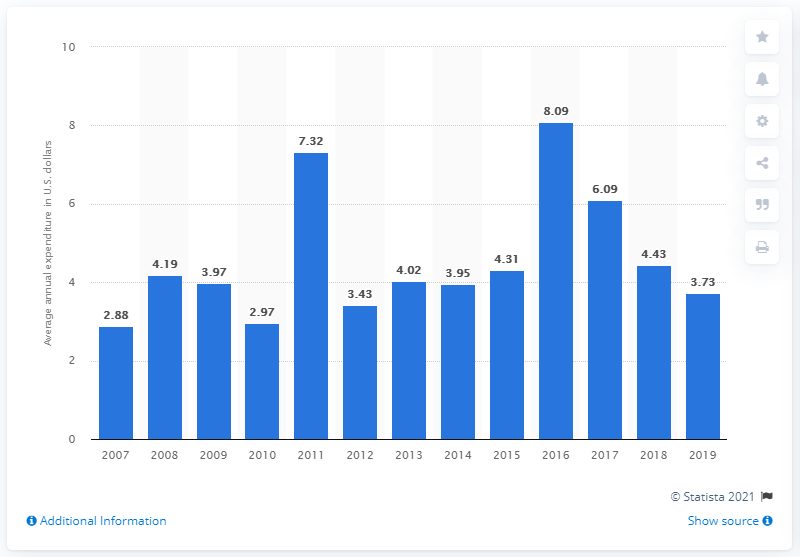Specify some key components in this picture. In the United States in 2019, the average expenditure on delivery services per consumer unit was 3.73 dollars. 